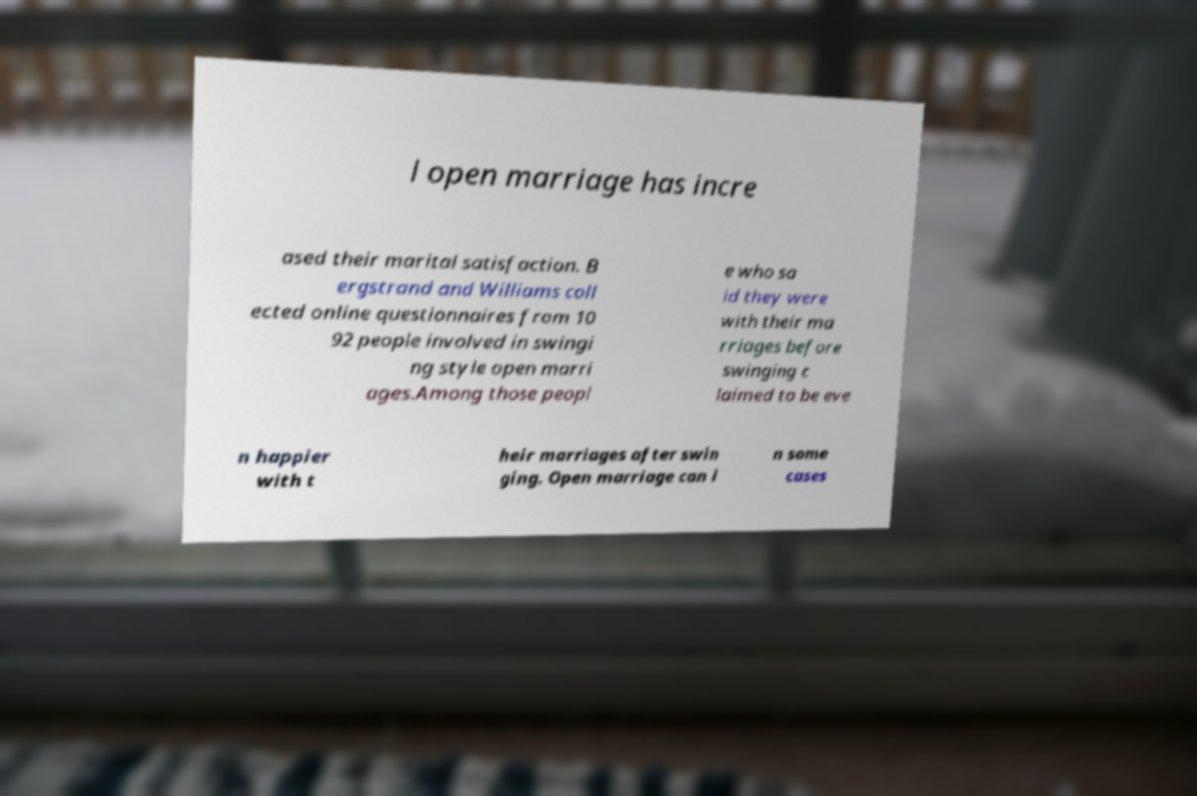There's text embedded in this image that I need extracted. Can you transcribe it verbatim? l open marriage has incre ased their marital satisfaction. B ergstrand and Williams coll ected online questionnaires from 10 92 people involved in swingi ng style open marri ages.Among those peopl e who sa id they were with their ma rriages before swinging c laimed to be eve n happier with t heir marriages after swin ging. Open marriage can i n some cases 